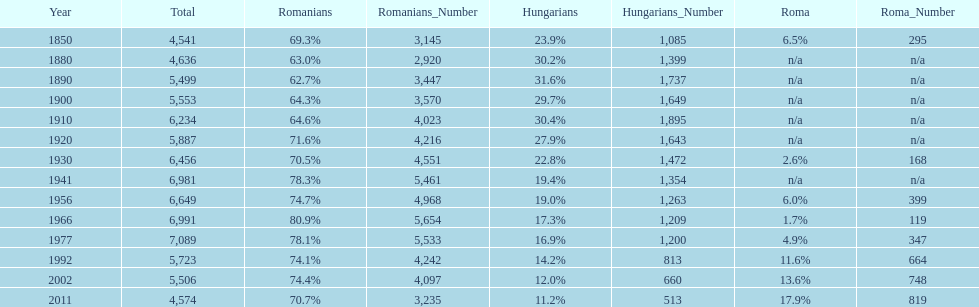What is the number of hungarians in 1850? 23.9%. 